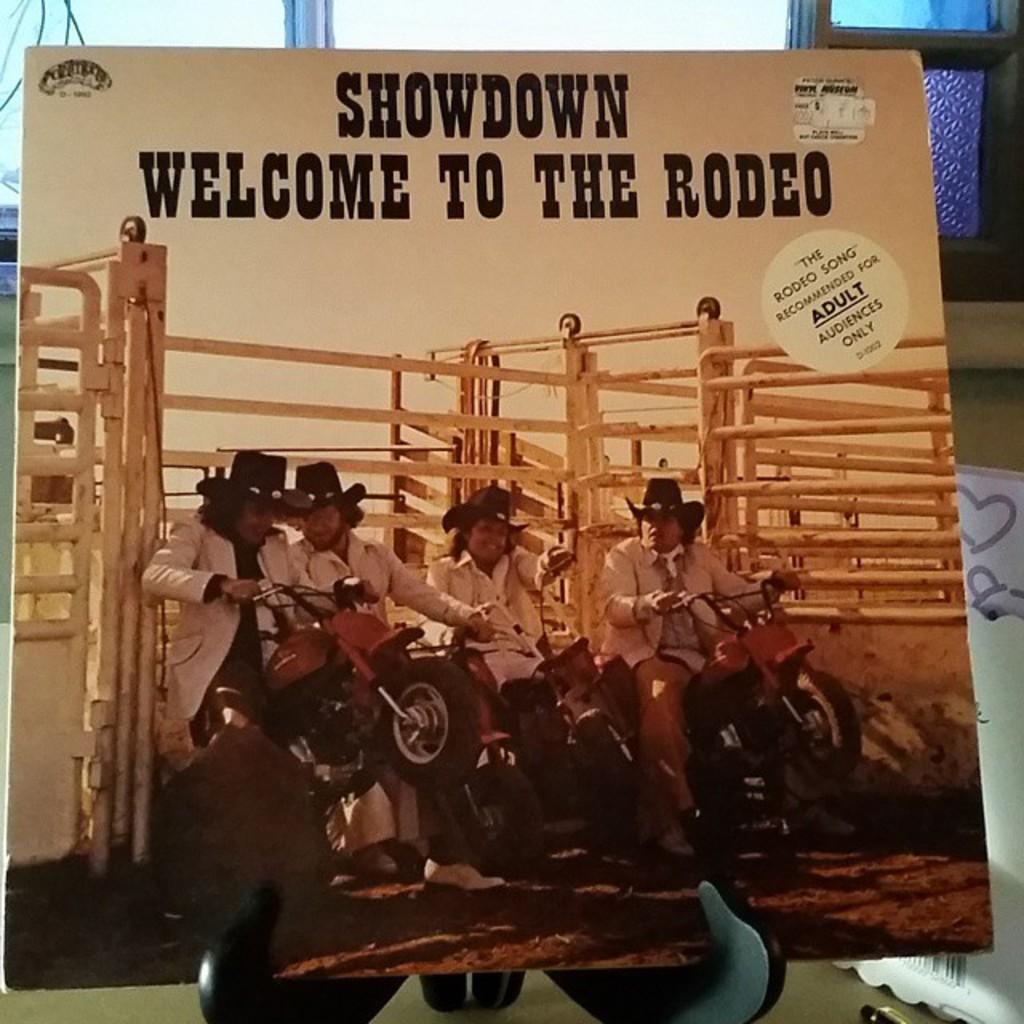Please provide a concise description of this image. In this picture there are few persons sitting on a bike and there is white fence behind them and there is something written above it. 